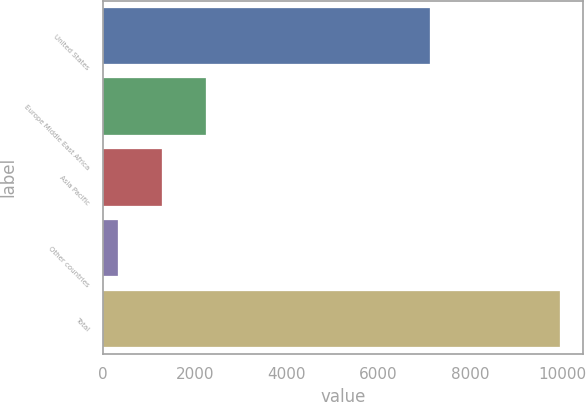Convert chart to OTSL. <chart><loc_0><loc_0><loc_500><loc_500><bar_chart><fcel>United States<fcel>Europe Middle East Africa<fcel>Asia Pacific<fcel>Other countries<fcel>Total<nl><fcel>7116<fcel>2238.8<fcel>1275.4<fcel>312<fcel>9946<nl></chart> 